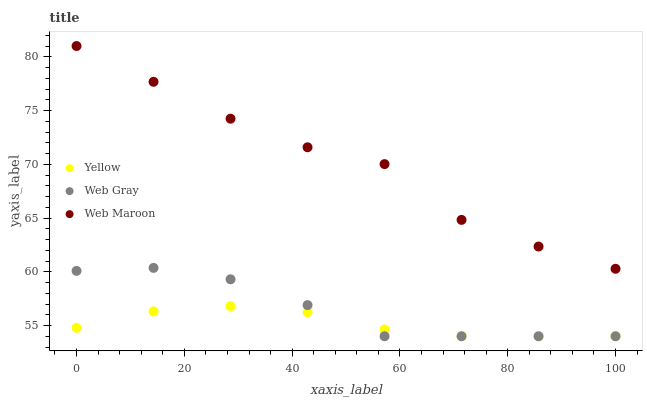Does Yellow have the minimum area under the curve?
Answer yes or no. Yes. Does Web Maroon have the maximum area under the curve?
Answer yes or no. Yes. Does Web Maroon have the minimum area under the curve?
Answer yes or no. No. Does Yellow have the maximum area under the curve?
Answer yes or no. No. Is Yellow the smoothest?
Answer yes or no. Yes. Is Web Maroon the roughest?
Answer yes or no. Yes. Is Web Maroon the smoothest?
Answer yes or no. No. Is Yellow the roughest?
Answer yes or no. No. Does Web Gray have the lowest value?
Answer yes or no. Yes. Does Web Maroon have the lowest value?
Answer yes or no. No. Does Web Maroon have the highest value?
Answer yes or no. Yes. Does Yellow have the highest value?
Answer yes or no. No. Is Web Gray less than Web Maroon?
Answer yes or no. Yes. Is Web Maroon greater than Yellow?
Answer yes or no. Yes. Does Yellow intersect Web Gray?
Answer yes or no. Yes. Is Yellow less than Web Gray?
Answer yes or no. No. Is Yellow greater than Web Gray?
Answer yes or no. No. Does Web Gray intersect Web Maroon?
Answer yes or no. No. 